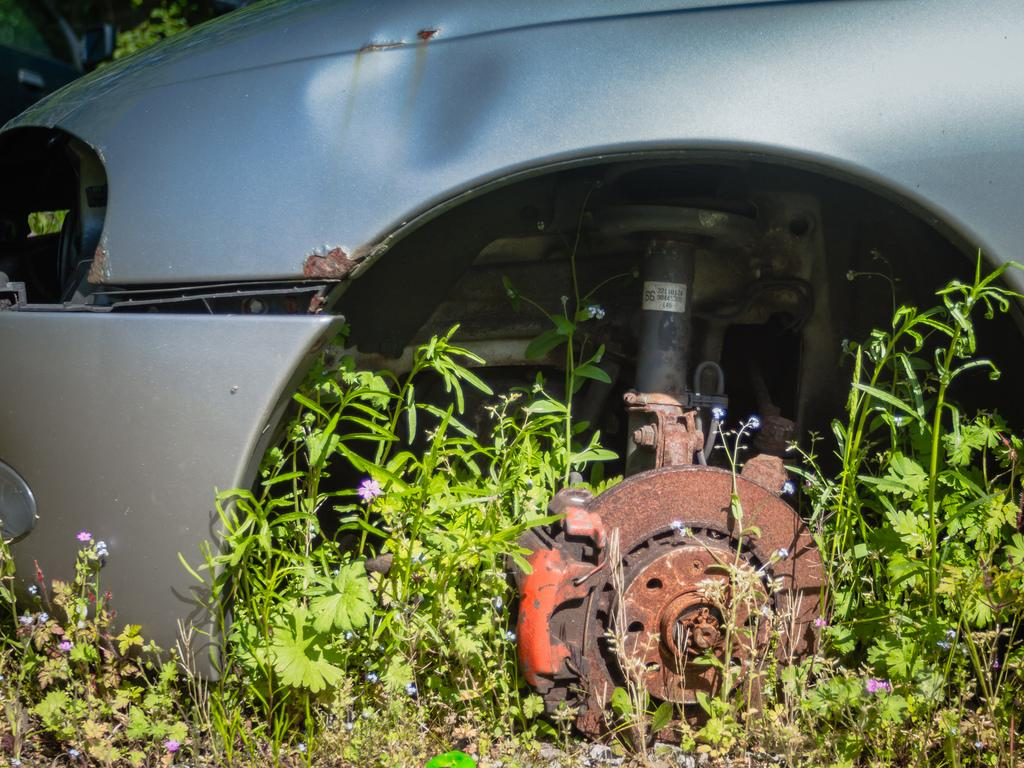What is the condition of the car in the image? The car in the image is missing a tire. What can be seen at the bottom of the image? There are plants at the bottom of the image. How does the snake stretch its body around the car in the image? There is no snake present in the image, so it cannot stretch its body around the car. 